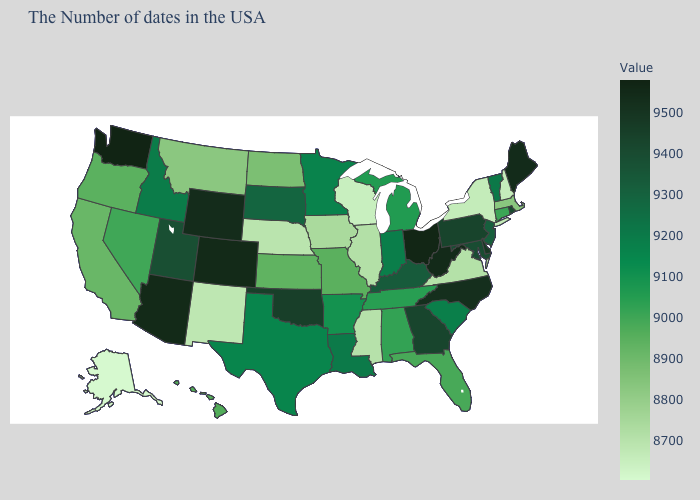Is the legend a continuous bar?
Write a very short answer. Yes. Is the legend a continuous bar?
Keep it brief. Yes. Does Utah have a lower value than Tennessee?
Concise answer only. No. Is the legend a continuous bar?
Concise answer only. Yes. Does Washington have the highest value in the USA?
Keep it brief. Yes. 